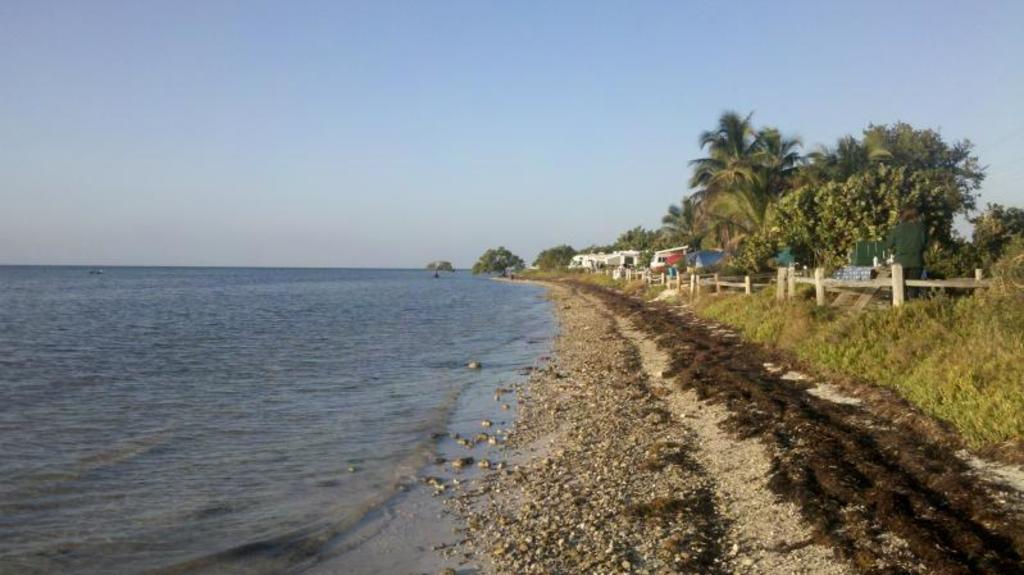How would you summarize this image in a sentence or two? In this picture we can see water, in the background we can find few plants, trees and houses. 